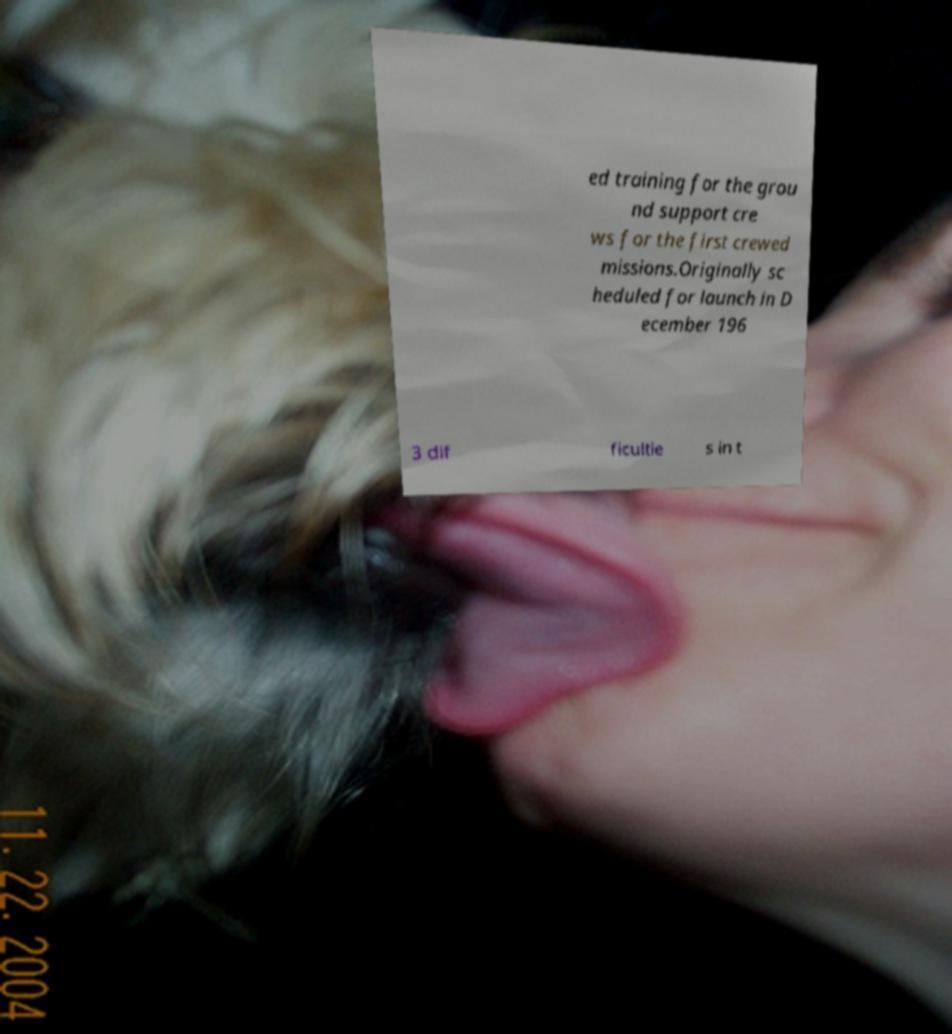There's text embedded in this image that I need extracted. Can you transcribe it verbatim? ed training for the grou nd support cre ws for the first crewed missions.Originally sc heduled for launch in D ecember 196 3 dif ficultie s in t 